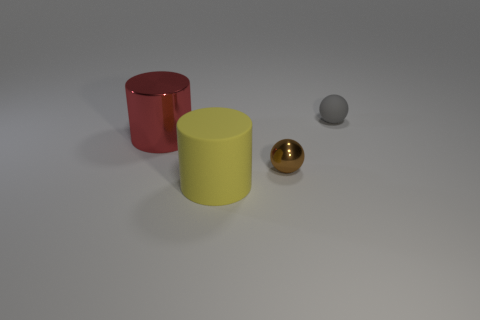Add 2 metal cylinders. How many objects exist? 6 Subtract all red cubes. How many yellow cylinders are left? 1 Subtract all large rubber objects. Subtract all shiny cylinders. How many objects are left? 2 Add 1 tiny metal spheres. How many tiny metal spheres are left? 2 Add 1 gray rubber objects. How many gray rubber objects exist? 2 Subtract all gray spheres. How many spheres are left? 1 Subtract 0 green balls. How many objects are left? 4 Subtract 2 balls. How many balls are left? 0 Subtract all gray spheres. Subtract all blue blocks. How many spheres are left? 1 